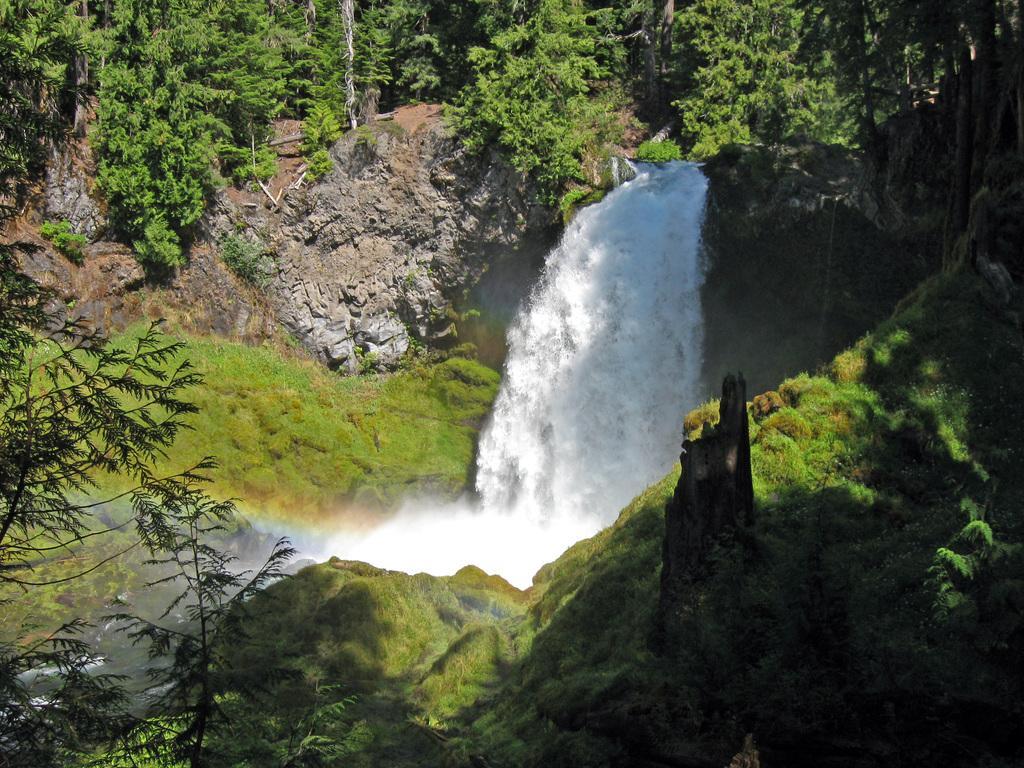In one or two sentences, can you explain what this image depicts? In this image we can see waterfall. Also there are rocks. And there are trees. And there's grass on the rocks. 